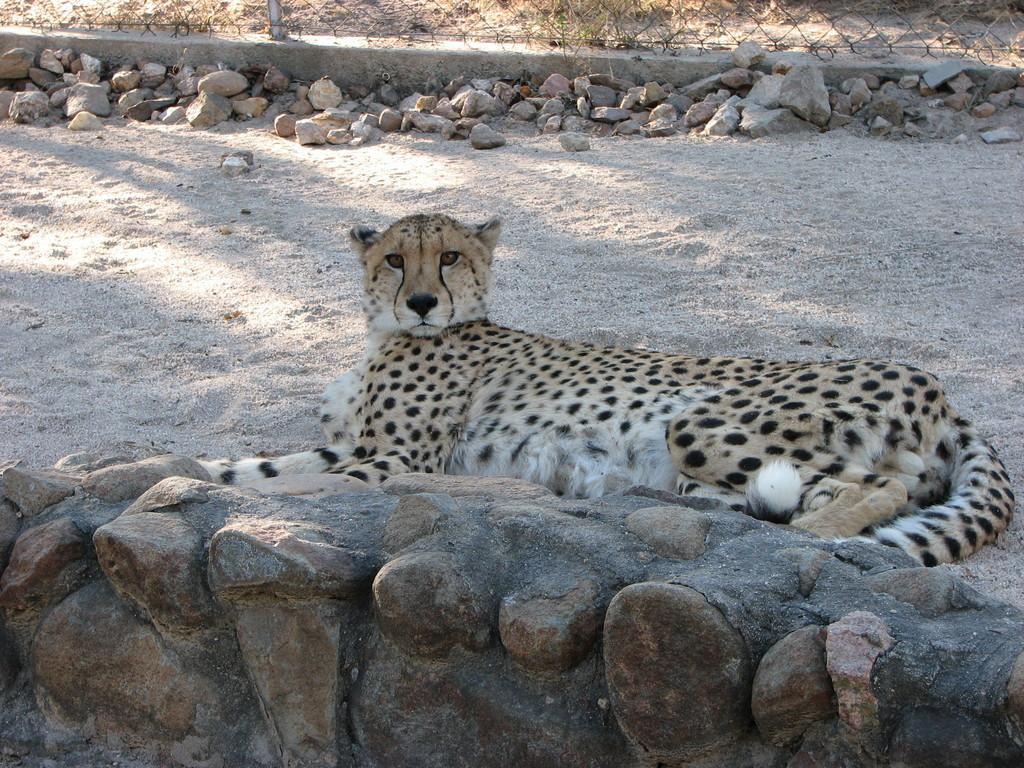What animal is laying on the ground in the image? There is a cheetah laying on the ground in the image. What is located at the bottom of the image? There is a wall at the bottom of the image. What can be seen in the background of the image? There are stones and a net visible in the background of the image. What type of underwear is the cheetah wearing in the image? Cheetahs do not wear underwear, as they are animals and do not wear clothing. 